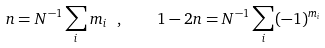<formula> <loc_0><loc_0><loc_500><loc_500>n = N ^ { - 1 } \sum _ { i } m _ { i } \ , \quad 1 - 2 n = N ^ { - 1 } \sum _ { i } ( - 1 ) ^ { m _ { i } }</formula> 